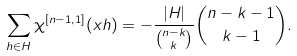Convert formula to latex. <formula><loc_0><loc_0><loc_500><loc_500>\sum _ { h \in H } \chi ^ { [ n - 1 , 1 ] } ( x h ) = - \frac { | H | } { \binom { n - k } { k } } \binom { n - k - 1 } { k - 1 } .</formula> 